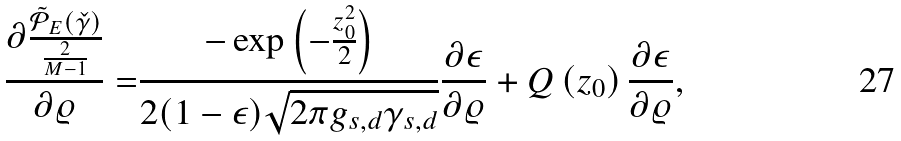Convert formula to latex. <formula><loc_0><loc_0><loc_500><loc_500>\frac { \partial \frac { \tilde { \mathcal { P } } _ { E } ( \check { \gamma } ) } { \frac { 2 } { M - 1 } } } { \partial \varrho } = & \frac { - \exp \left ( - \frac { z _ { 0 } ^ { 2 } } { 2 } \right ) } { 2 ( 1 - \epsilon ) \sqrt { 2 \pi g _ { s , d } \gamma _ { s , d } } } \frac { \partial \epsilon } { \partial \varrho } + Q \left ( z _ { 0 } \right ) \frac { \partial \epsilon } { \partial \varrho } ,</formula> 